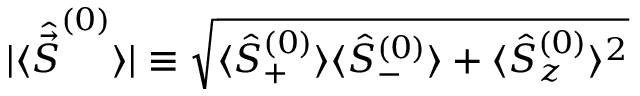Convert formula to latex. <formula><loc_0><loc_0><loc_500><loc_500>| \langle \hat { \vec { S } } ^ { ( 0 ) } \rangle | \equiv \sqrt { \langle \hat { S } _ { + } ^ { ( 0 ) } \rangle \langle \hat { S } _ { - } ^ { ( 0 ) } \rangle + \langle \hat { S } _ { z } ^ { ( 0 ) } \rangle ^ { 2 } }</formula> 